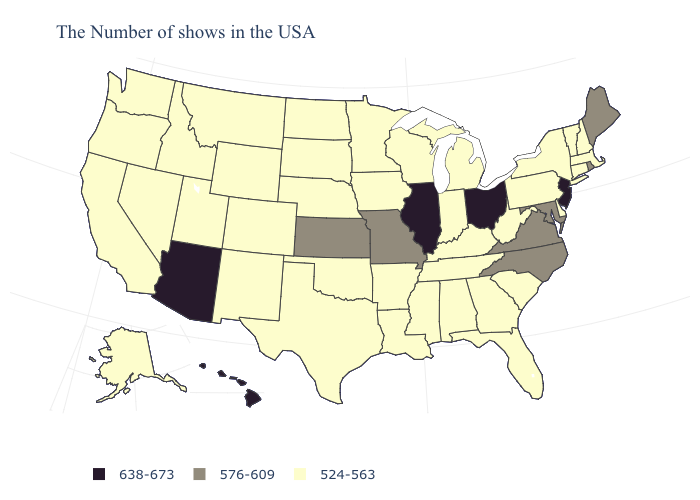Does Utah have the lowest value in the West?
Concise answer only. Yes. Name the states that have a value in the range 638-673?
Short answer required. New Jersey, Ohio, Illinois, Arizona, Hawaii. What is the value of Oklahoma?
Keep it brief. 524-563. What is the highest value in the USA?
Keep it brief. 638-673. Name the states that have a value in the range 638-673?
Keep it brief. New Jersey, Ohio, Illinois, Arizona, Hawaii. What is the highest value in the USA?
Keep it brief. 638-673. Among the states that border Tennessee , which have the highest value?
Keep it brief. Virginia, North Carolina, Missouri. What is the value of Georgia?
Keep it brief. 524-563. Does the first symbol in the legend represent the smallest category?
Write a very short answer. No. Does South Dakota have a higher value than Hawaii?
Short answer required. No. What is the value of Arkansas?
Quick response, please. 524-563. Does Kentucky have the same value as Maryland?
Concise answer only. No. Among the states that border Oklahoma , does Texas have the lowest value?
Answer briefly. Yes. 